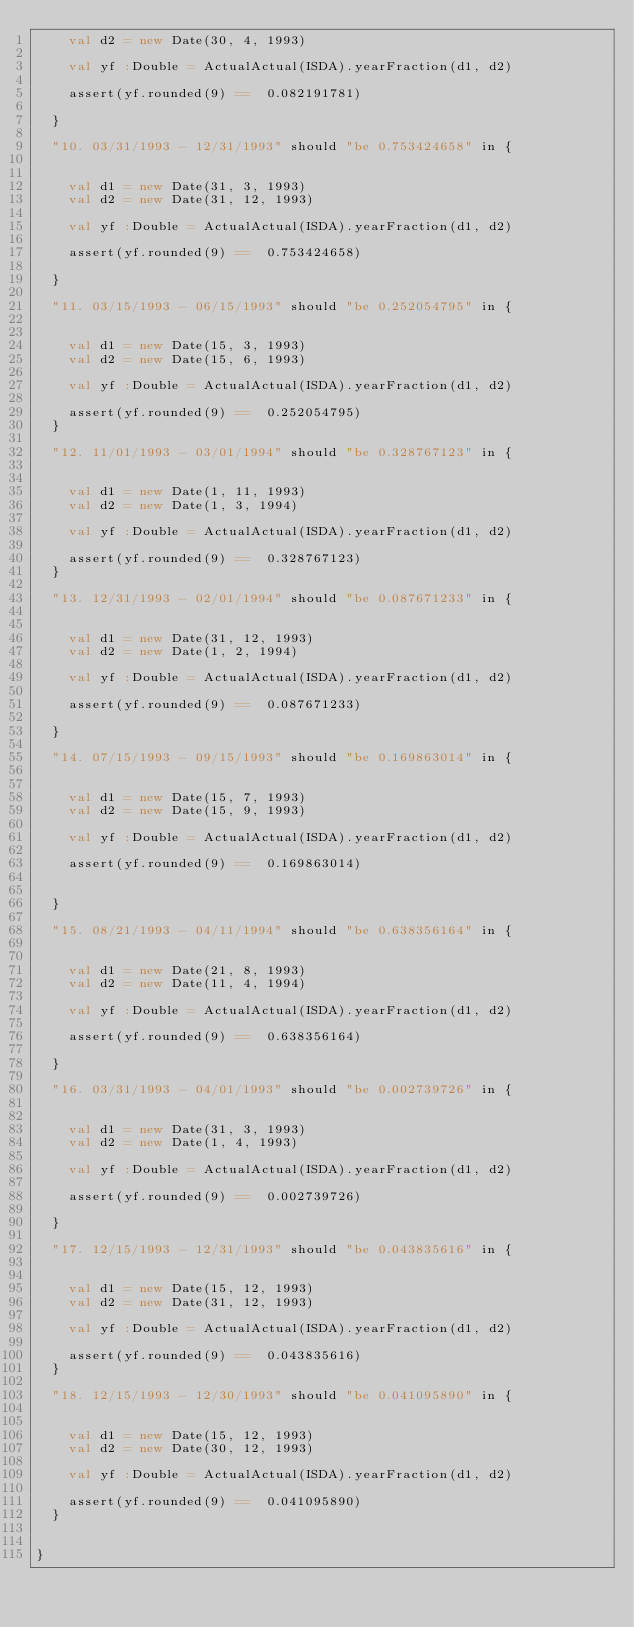<code> <loc_0><loc_0><loc_500><loc_500><_Scala_>    val d2 = new Date(30, 4, 1993)

    val yf :Double = ActualActual(ISDA).yearFraction(d1, d2)

    assert(yf.rounded(9) ==  0.082191781)

  }

  "10. 03/31/1993 - 12/31/1993" should "be 0.753424658" in {


    val d1 = new Date(31, 3, 1993)
    val d2 = new Date(31, 12, 1993)

    val yf :Double = ActualActual(ISDA).yearFraction(d1, d2)

    assert(yf.rounded(9) ==  0.753424658)

  }

  "11. 03/15/1993 - 06/15/1993" should "be 0.252054795" in {


    val d1 = new Date(15, 3, 1993)
    val d2 = new Date(15, 6, 1993)

    val yf :Double = ActualActual(ISDA).yearFraction(d1, d2)

    assert(yf.rounded(9) ==  0.252054795)
  }

  "12. 11/01/1993 - 03/01/1994" should "be 0.328767123" in {


    val d1 = new Date(1, 11, 1993)
    val d2 = new Date(1, 3, 1994)

    val yf :Double = ActualActual(ISDA).yearFraction(d1, d2)

    assert(yf.rounded(9) ==  0.328767123)
  }

  "13. 12/31/1993 - 02/01/1994" should "be 0.087671233" in {


    val d1 = new Date(31, 12, 1993)
    val d2 = new Date(1, 2, 1994)

    val yf :Double = ActualActual(ISDA).yearFraction(d1, d2)

    assert(yf.rounded(9) ==  0.087671233)

  }

  "14. 07/15/1993 - 09/15/1993" should "be 0.169863014" in {


    val d1 = new Date(15, 7, 1993)
    val d2 = new Date(15, 9, 1993)

    val yf :Double = ActualActual(ISDA).yearFraction(d1, d2)

    assert(yf.rounded(9) ==  0.169863014)


  }

  "15. 08/21/1993 - 04/11/1994" should "be 0.638356164" in {


    val d1 = new Date(21, 8, 1993)
    val d2 = new Date(11, 4, 1994)

    val yf :Double = ActualActual(ISDA).yearFraction(d1, d2)

    assert(yf.rounded(9) ==  0.638356164)

  }

  "16. 03/31/1993 - 04/01/1993" should "be 0.002739726" in {


    val d1 = new Date(31, 3, 1993)
    val d2 = new Date(1, 4, 1993)

    val yf :Double = ActualActual(ISDA).yearFraction(d1, d2)

    assert(yf.rounded(9) ==  0.002739726)

  }

  "17. 12/15/1993 - 12/31/1993" should "be 0.043835616" in {


    val d1 = new Date(15, 12, 1993)
    val d2 = new Date(31, 12, 1993)
    
    val yf :Double = ActualActual(ISDA).yearFraction(d1, d2)

    assert(yf.rounded(9) ==  0.043835616)
  }

  "18. 12/15/1993 - 12/30/1993" should "be 0.041095890" in {


    val d1 = new Date(15, 12, 1993)
    val d2 = new Date(30, 12, 1993)

    val yf :Double = ActualActual(ISDA).yearFraction(d1, d2)

    assert(yf.rounded(9) ==  0.041095890)
  }


}
</code> 